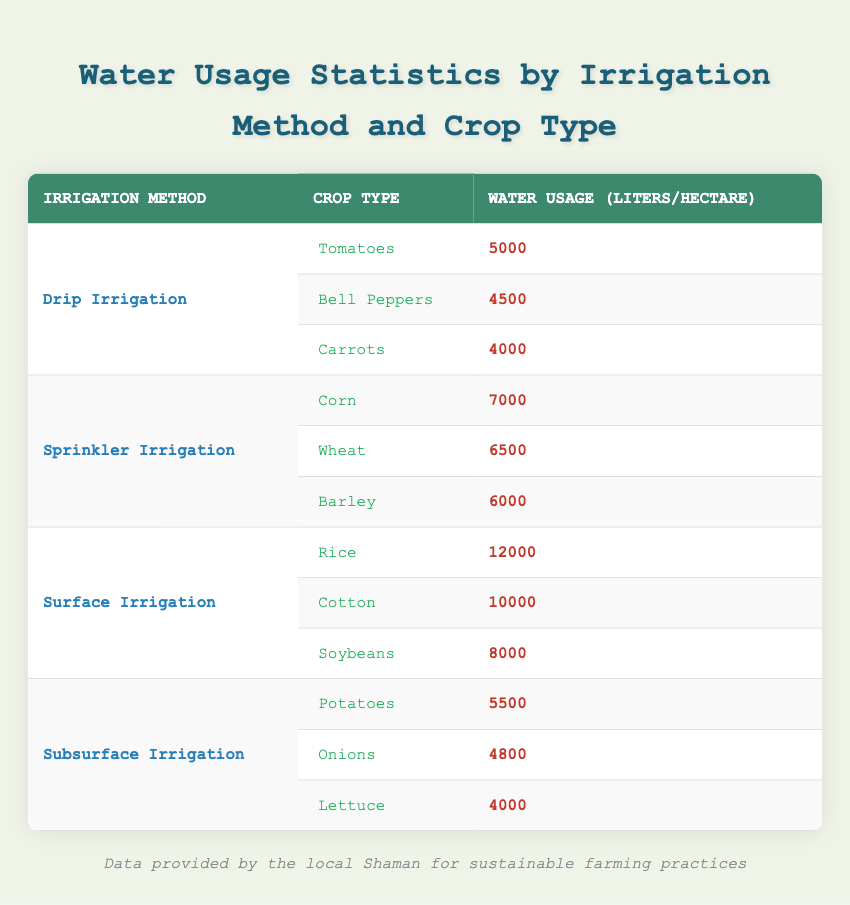What is the water usage for tomatoes? Tomatoes are listed under Drip Irrigation with a water usage of 5000 liters per hectare.
Answer: 5000 liters per hectare Which irrigation method uses the least water for carrots? Carrots are grown using Drip Irrigation, where the water usage is 4000 liters per hectare, which is less than any other method for this crop type.
Answer: Drip Irrigation What is the total water usage for crops under Surface Irrigation? The total water usage for crops under Surface Irrigation is calculated as follows: Rice (12000) + Cotton (10000) + Soybeans (8000) = 30000 liters per hectare.
Answer: 30000 liters per hectare Is the water usage for onions higher than for lettuce? Onions have a water usage of 4800 liters per hectare, while lettuce has a usage of 4000 liters per hectare. Since 4800 is greater than 4000, the statement is true.
Answer: Yes Which irrigation method has the highest water usage average? To find the average water usage for each method, we calculate: Drip Irrigation = (5000 + 4500 + 4000)/3 = 4500, Sprinkler Irrigation = (7000 + 6500 + 6000)/3 = 6500, Surface Irrigation = (12000 + 10000 + 8000)/3 = 10000, Subsurface Irrigation = (5500 + 4800 + 4000)/3 = 4766.67. Surface Irrigation has the highest average at 10000 liters per hectare.
Answer: Surface Irrigation How much more water does rice require compared to bell peppers? Rice requires 12000 liters per hectare, while bell peppers require 4500 liters per hectare. The difference is calculated as 12000 - 4500 = 7500 liters per hectare.
Answer: 7500 liters per hectare 